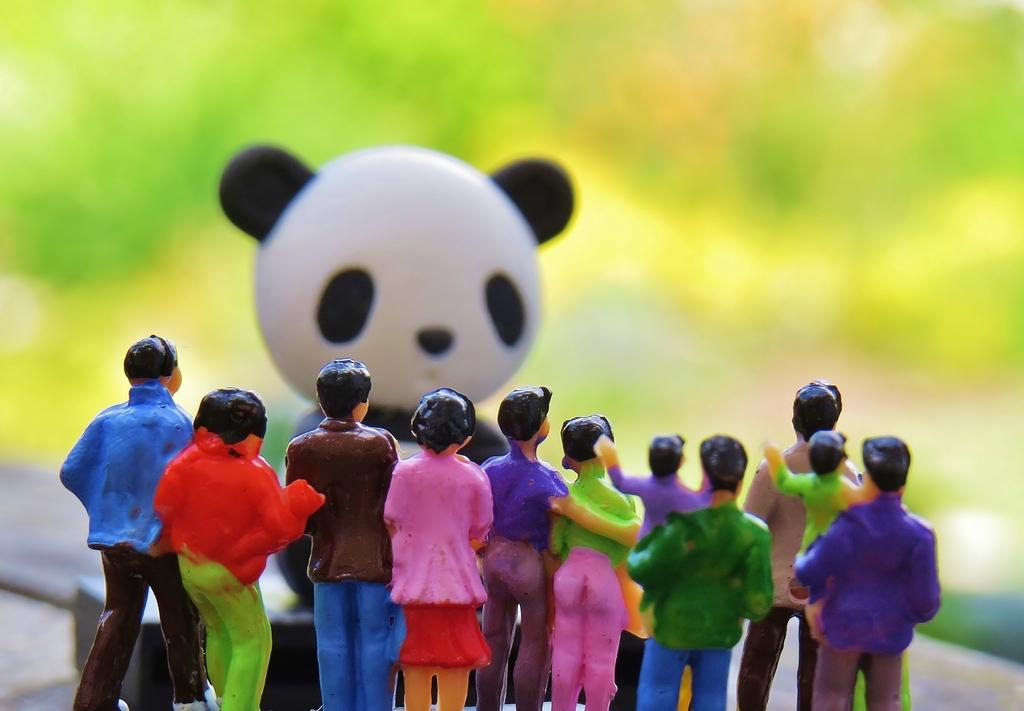What objects can be seen in the image? There are toys in the image. What can be seen in the distance in the image? There is greenery in the background of the image. What type of question is being asked in the image? There is no question present in the image; it features toys and greenery in the background. 